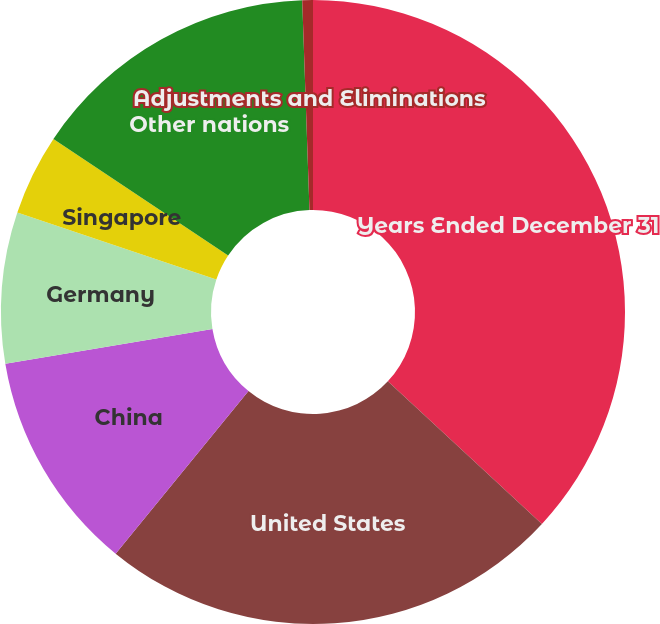Convert chart. <chart><loc_0><loc_0><loc_500><loc_500><pie_chart><fcel>Years Ended December 31<fcel>United States<fcel>China<fcel>Germany<fcel>Singapore<fcel>Other nations<fcel>Adjustments and Eliminations<nl><fcel>36.89%<fcel>24.01%<fcel>11.45%<fcel>7.82%<fcel>4.19%<fcel>15.09%<fcel>0.55%<nl></chart> 